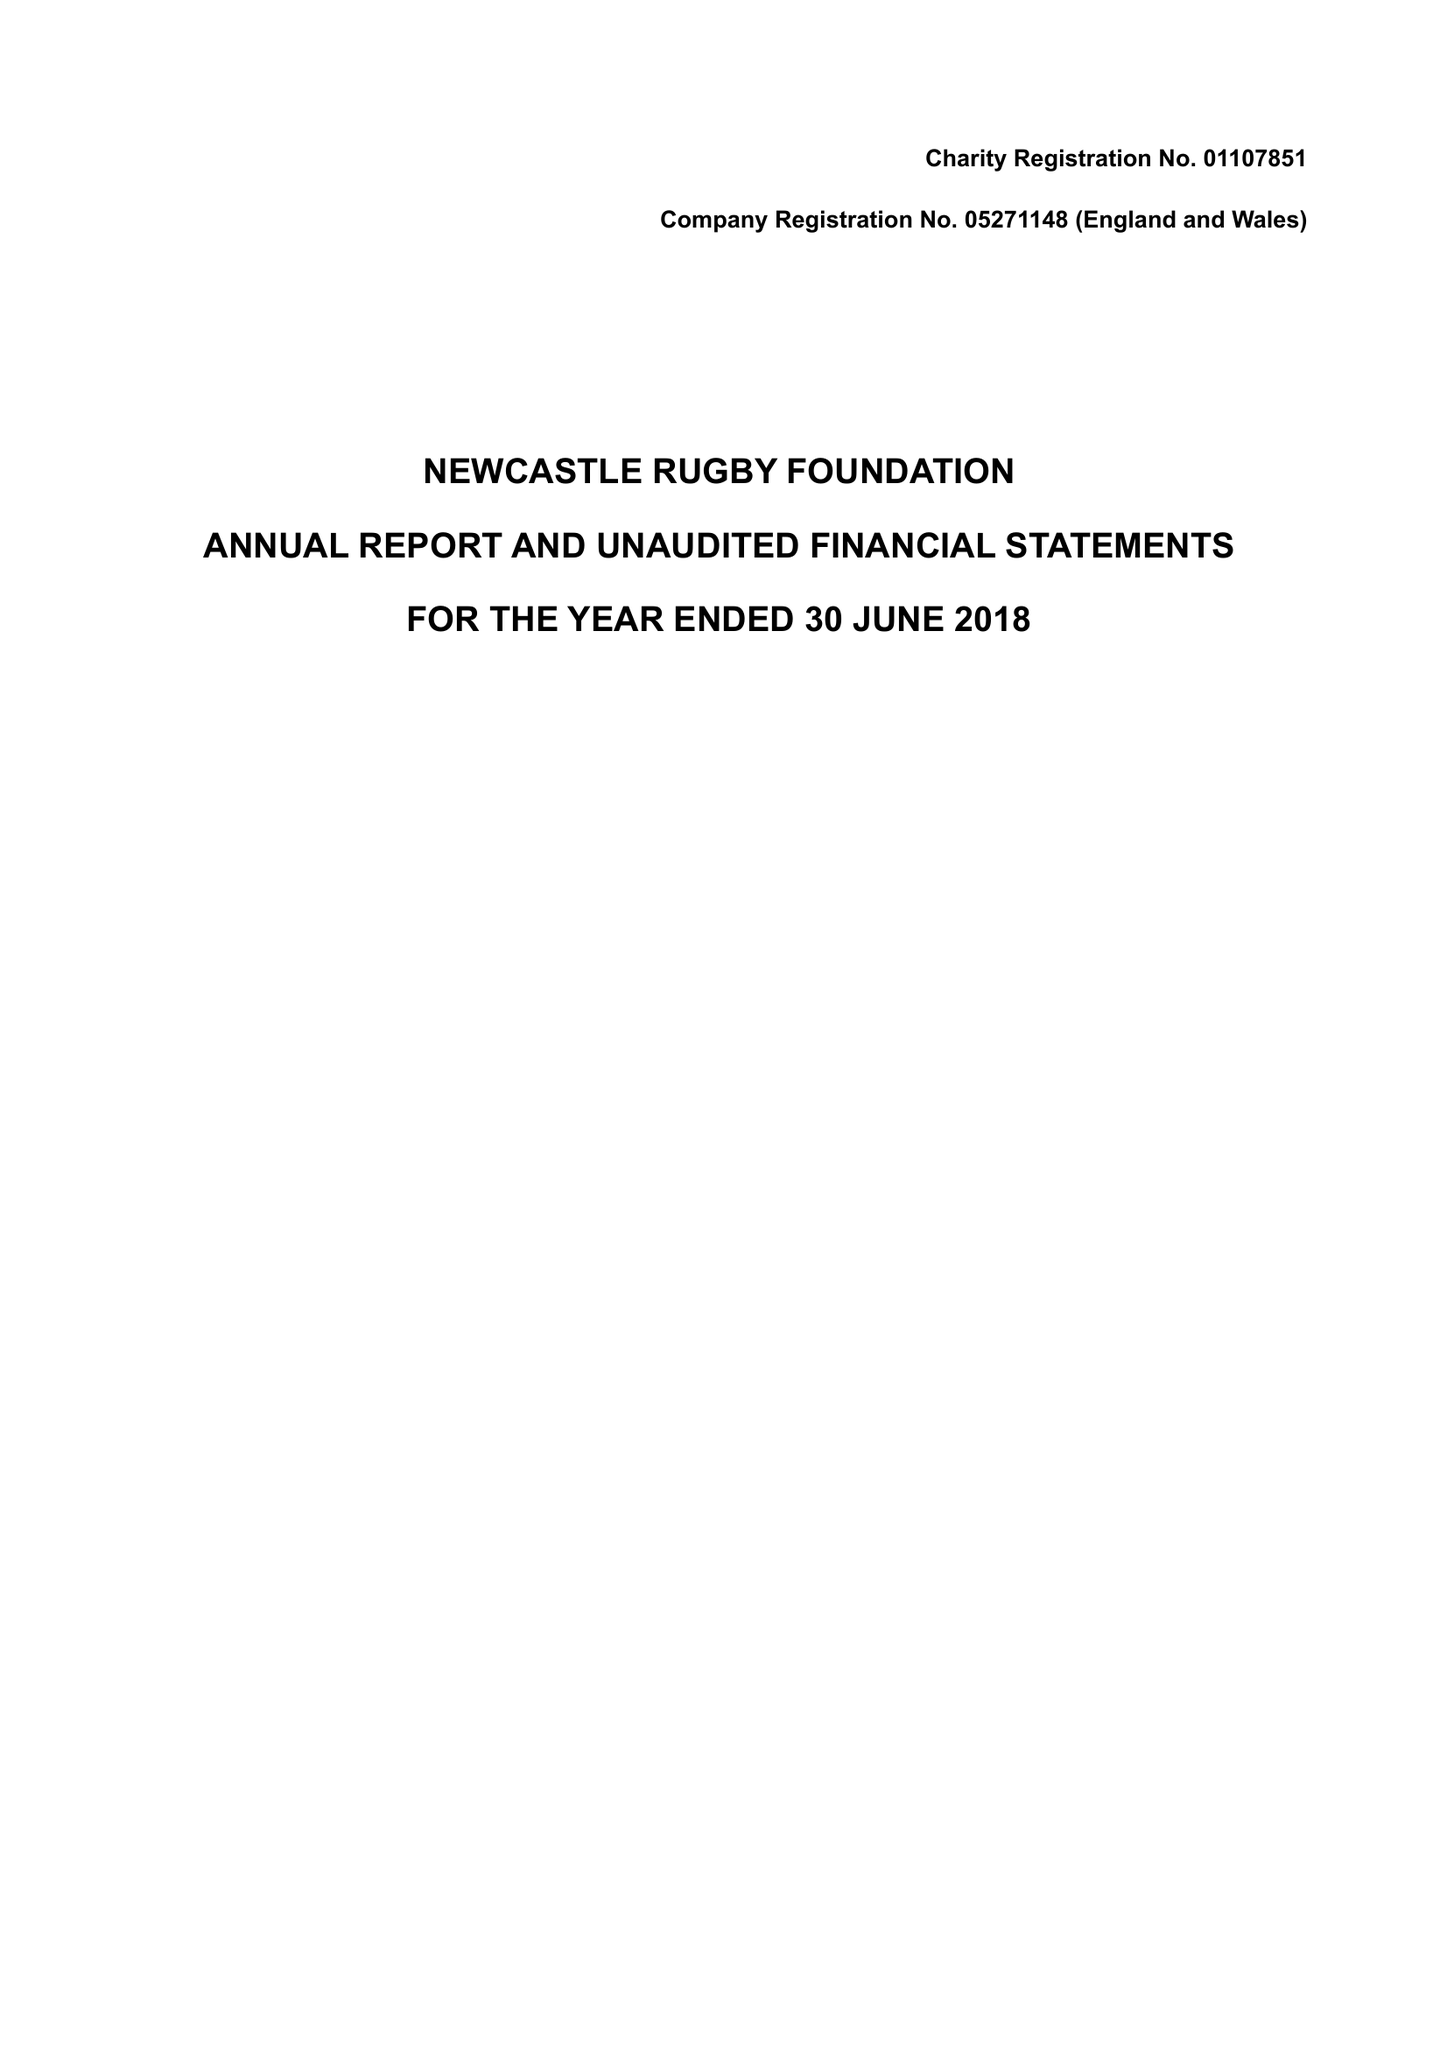What is the value for the spending_annually_in_british_pounds?
Answer the question using a single word or phrase. 271734.00 